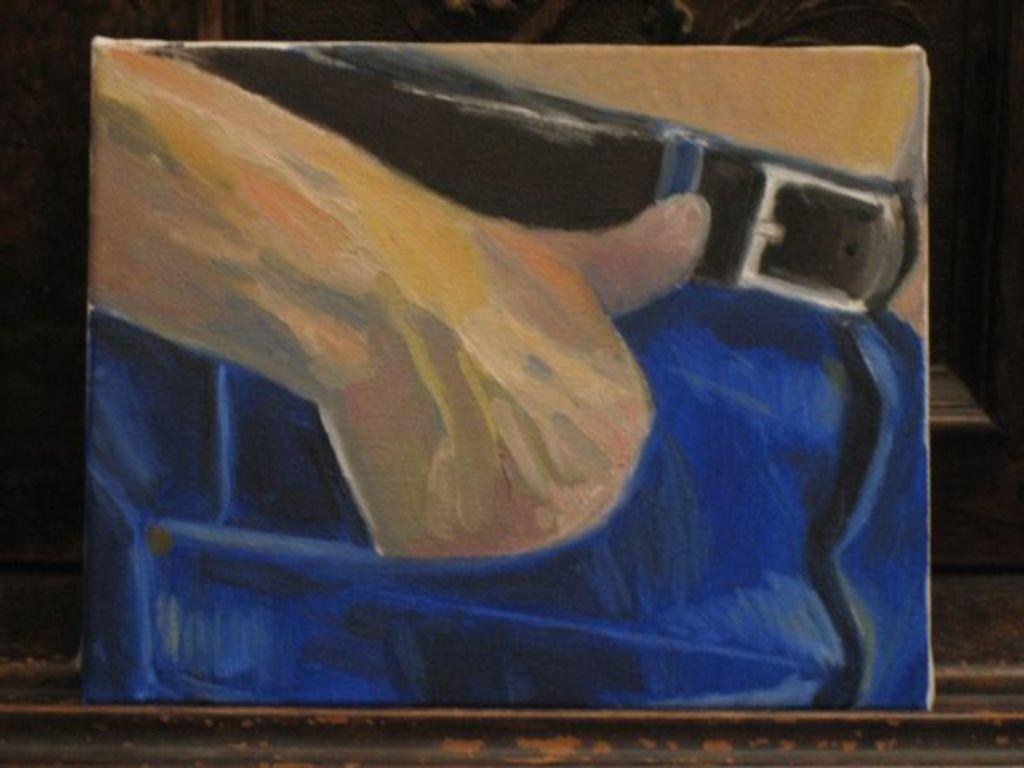What is the main subject of the image? There is a painting in the image. What is the painting depicting? The painting depicts a person's hand in their pocket. What is the painting placed on? The painting is placed on a wooden surface. What accessory is visible in the painting? A belt is visible in the painting. How much money is the person holding in the painting? There is no money visible in the painting; it depicts a person's hand in their pocket with a belt. 